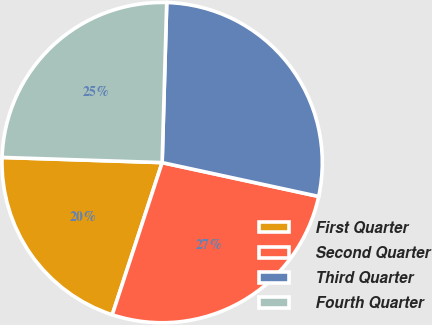Convert chart to OTSL. <chart><loc_0><loc_0><loc_500><loc_500><pie_chart><fcel>First Quarter<fcel>Second Quarter<fcel>Third Quarter<fcel>Fourth Quarter<nl><fcel>20.47%<fcel>26.65%<fcel>27.93%<fcel>24.94%<nl></chart> 